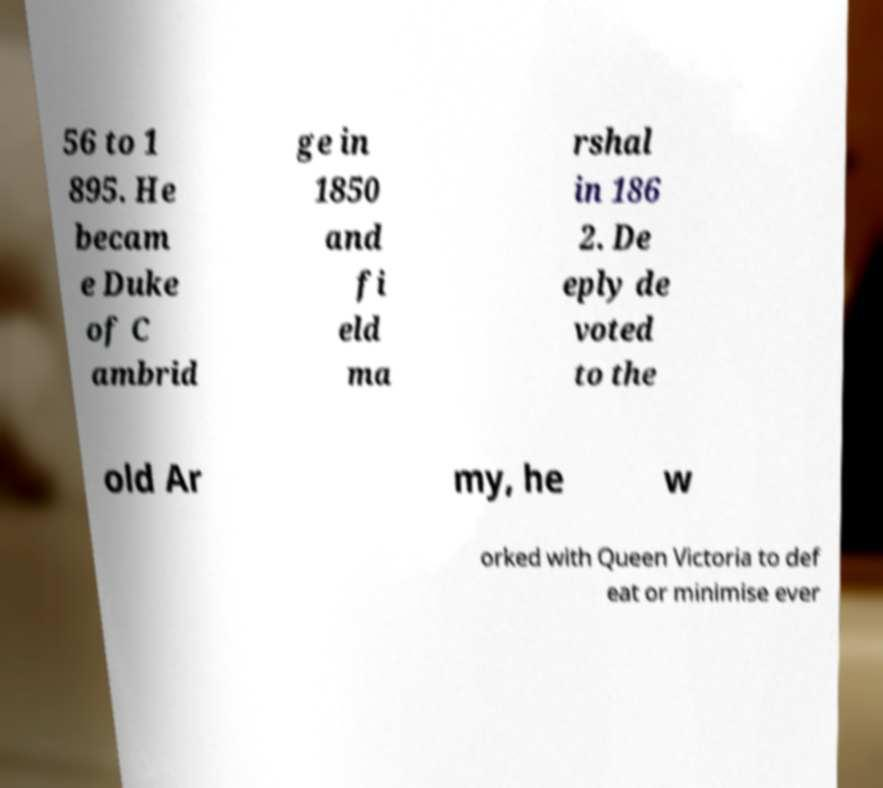What messages or text are displayed in this image? I need them in a readable, typed format. 56 to 1 895. He becam e Duke of C ambrid ge in 1850 and fi eld ma rshal in 186 2. De eply de voted to the old Ar my, he w orked with Queen Victoria to def eat or minimise ever 